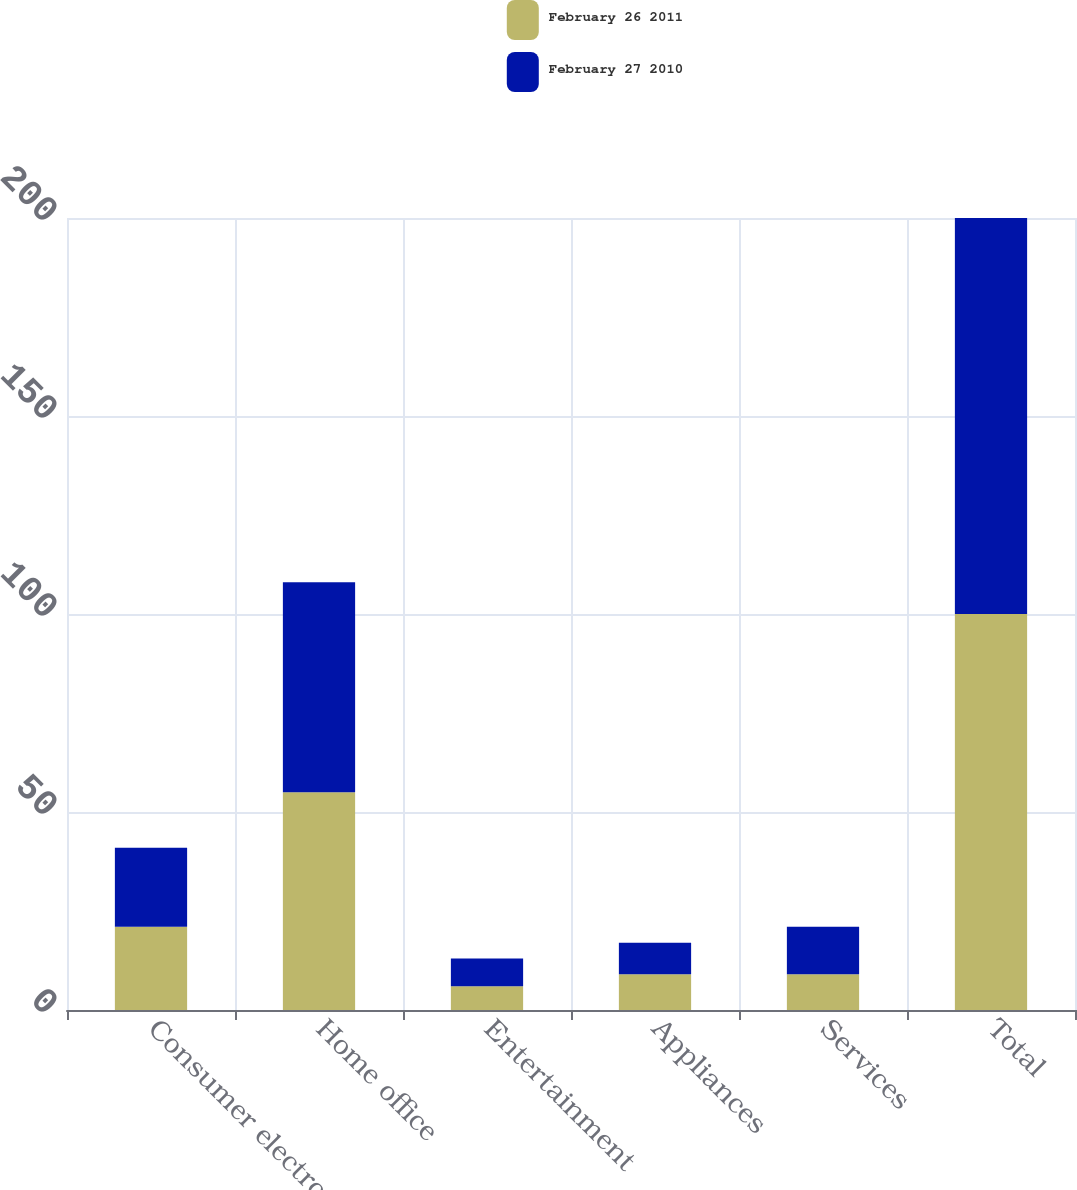Convert chart to OTSL. <chart><loc_0><loc_0><loc_500><loc_500><stacked_bar_chart><ecel><fcel>Consumer electronics<fcel>Home office<fcel>Entertainment<fcel>Appliances<fcel>Services<fcel>Total<nl><fcel>February 26 2011<fcel>21<fcel>55<fcel>6<fcel>9<fcel>9<fcel>100<nl><fcel>February 27 2010<fcel>20<fcel>53<fcel>7<fcel>8<fcel>12<fcel>100<nl></chart> 